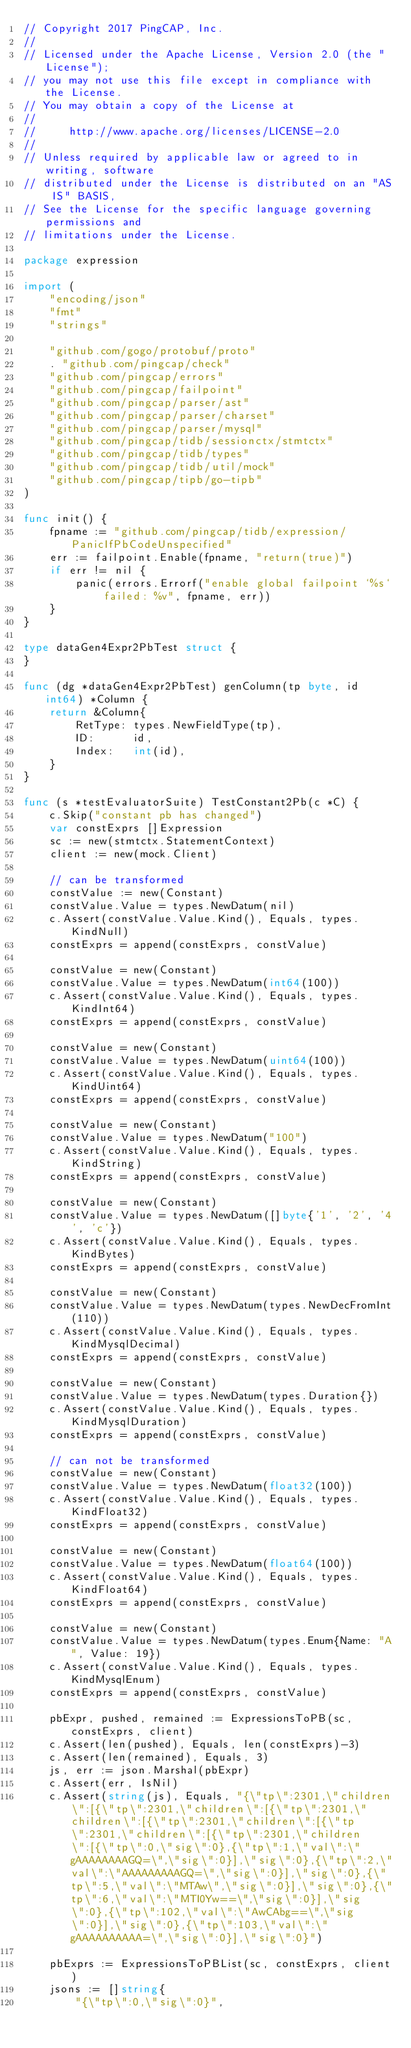Convert code to text. <code><loc_0><loc_0><loc_500><loc_500><_Go_>// Copyright 2017 PingCAP, Inc.
//
// Licensed under the Apache License, Version 2.0 (the "License");
// you may not use this file except in compliance with the License.
// You may obtain a copy of the License at
//
//     http://www.apache.org/licenses/LICENSE-2.0
//
// Unless required by applicable law or agreed to in writing, software
// distributed under the License is distributed on an "AS IS" BASIS,
// See the License for the specific language governing permissions and
// limitations under the License.

package expression

import (
	"encoding/json"
	"fmt"
	"strings"

	"github.com/gogo/protobuf/proto"
	. "github.com/pingcap/check"
	"github.com/pingcap/errors"
	"github.com/pingcap/failpoint"
	"github.com/pingcap/parser/ast"
	"github.com/pingcap/parser/charset"
	"github.com/pingcap/parser/mysql"
	"github.com/pingcap/tidb/sessionctx/stmtctx"
	"github.com/pingcap/tidb/types"
	"github.com/pingcap/tidb/util/mock"
	"github.com/pingcap/tipb/go-tipb"
)

func init() {
	fpname := "github.com/pingcap/tidb/expression/PanicIfPbCodeUnspecified"
	err := failpoint.Enable(fpname, "return(true)")
	if err != nil {
		panic(errors.Errorf("enable global failpoint `%s` failed: %v", fpname, err))
	}
}

type dataGen4Expr2PbTest struct {
}

func (dg *dataGen4Expr2PbTest) genColumn(tp byte, id int64) *Column {
	return &Column{
		RetType: types.NewFieldType(tp),
		ID:      id,
		Index:   int(id),
	}
}

func (s *testEvaluatorSuite) TestConstant2Pb(c *C) {
	c.Skip("constant pb has changed")
	var constExprs []Expression
	sc := new(stmtctx.StatementContext)
	client := new(mock.Client)

	// can be transformed
	constValue := new(Constant)
	constValue.Value = types.NewDatum(nil)
	c.Assert(constValue.Value.Kind(), Equals, types.KindNull)
	constExprs = append(constExprs, constValue)

	constValue = new(Constant)
	constValue.Value = types.NewDatum(int64(100))
	c.Assert(constValue.Value.Kind(), Equals, types.KindInt64)
	constExprs = append(constExprs, constValue)

	constValue = new(Constant)
	constValue.Value = types.NewDatum(uint64(100))
	c.Assert(constValue.Value.Kind(), Equals, types.KindUint64)
	constExprs = append(constExprs, constValue)

	constValue = new(Constant)
	constValue.Value = types.NewDatum("100")
	c.Assert(constValue.Value.Kind(), Equals, types.KindString)
	constExprs = append(constExprs, constValue)

	constValue = new(Constant)
	constValue.Value = types.NewDatum([]byte{'1', '2', '4', 'c'})
	c.Assert(constValue.Value.Kind(), Equals, types.KindBytes)
	constExprs = append(constExprs, constValue)

	constValue = new(Constant)
	constValue.Value = types.NewDatum(types.NewDecFromInt(110))
	c.Assert(constValue.Value.Kind(), Equals, types.KindMysqlDecimal)
	constExprs = append(constExprs, constValue)

	constValue = new(Constant)
	constValue.Value = types.NewDatum(types.Duration{})
	c.Assert(constValue.Value.Kind(), Equals, types.KindMysqlDuration)
	constExprs = append(constExprs, constValue)

	// can not be transformed
	constValue = new(Constant)
	constValue.Value = types.NewDatum(float32(100))
	c.Assert(constValue.Value.Kind(), Equals, types.KindFloat32)
	constExprs = append(constExprs, constValue)

	constValue = new(Constant)
	constValue.Value = types.NewDatum(float64(100))
	c.Assert(constValue.Value.Kind(), Equals, types.KindFloat64)
	constExprs = append(constExprs, constValue)

	constValue = new(Constant)
	constValue.Value = types.NewDatum(types.Enum{Name: "A", Value: 19})
	c.Assert(constValue.Value.Kind(), Equals, types.KindMysqlEnum)
	constExprs = append(constExprs, constValue)

	pbExpr, pushed, remained := ExpressionsToPB(sc, constExprs, client)
	c.Assert(len(pushed), Equals, len(constExprs)-3)
	c.Assert(len(remained), Equals, 3)
	js, err := json.Marshal(pbExpr)
	c.Assert(err, IsNil)
	c.Assert(string(js), Equals, "{\"tp\":2301,\"children\":[{\"tp\":2301,\"children\":[{\"tp\":2301,\"children\":[{\"tp\":2301,\"children\":[{\"tp\":2301,\"children\":[{\"tp\":2301,\"children\":[{\"tp\":0,\"sig\":0},{\"tp\":1,\"val\":\"gAAAAAAAAGQ=\",\"sig\":0}],\"sig\":0},{\"tp\":2,\"val\":\"AAAAAAAAAGQ=\",\"sig\":0}],\"sig\":0},{\"tp\":5,\"val\":\"MTAw\",\"sig\":0}],\"sig\":0},{\"tp\":6,\"val\":\"MTI0Yw==\",\"sig\":0}],\"sig\":0},{\"tp\":102,\"val\":\"AwCAbg==\",\"sig\":0}],\"sig\":0},{\"tp\":103,\"val\":\"gAAAAAAAAAA=\",\"sig\":0}],\"sig\":0}")

	pbExprs := ExpressionsToPBList(sc, constExprs, client)
	jsons := []string{
		"{\"tp\":0,\"sig\":0}",</code> 